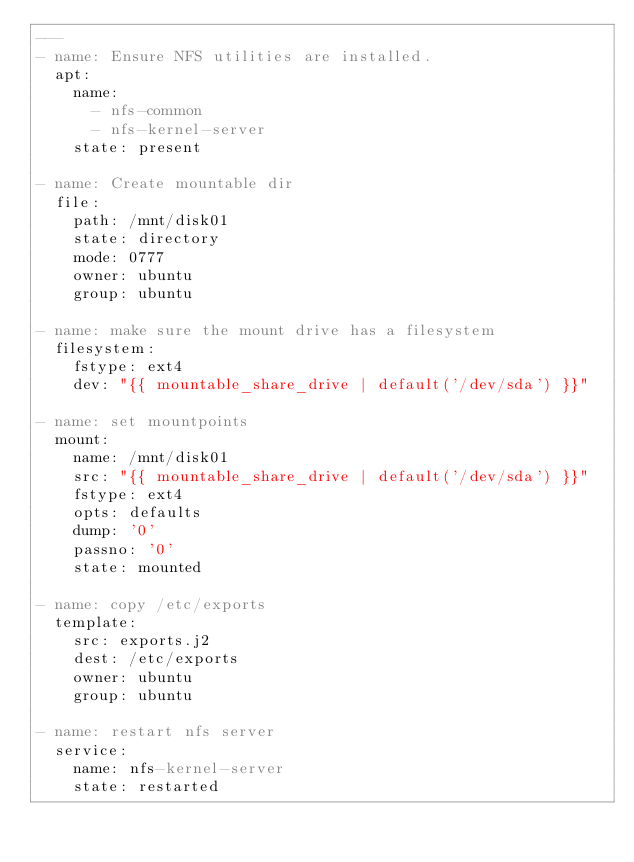<code> <loc_0><loc_0><loc_500><loc_500><_YAML_>---
- name: Ensure NFS utilities are installed.
  apt:
    name:
      - nfs-common
      - nfs-kernel-server
    state: present

- name: Create mountable dir
  file:
    path: /mnt/disk01
    state: directory
    mode: 0777
    owner: ubuntu
    group: ubuntu

- name: make sure the mount drive has a filesystem
  filesystem:
    fstype: ext4
    dev: "{{ mountable_share_drive | default('/dev/sda') }}"

- name: set mountpoints
  mount:
    name: /mnt/disk01
    src: "{{ mountable_share_drive | default('/dev/sda') }}"
    fstype: ext4
    opts: defaults
    dump: '0'
    passno: '0'
    state: mounted

- name: copy /etc/exports
  template:
    src: exports.j2
    dest: /etc/exports
    owner: ubuntu
    group: ubuntu

- name: restart nfs server
  service:
    name: nfs-kernel-server
    state: restarted
</code> 